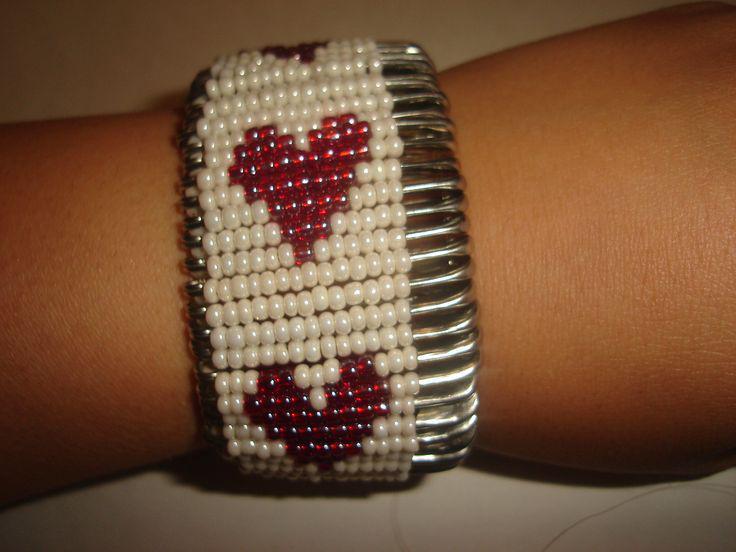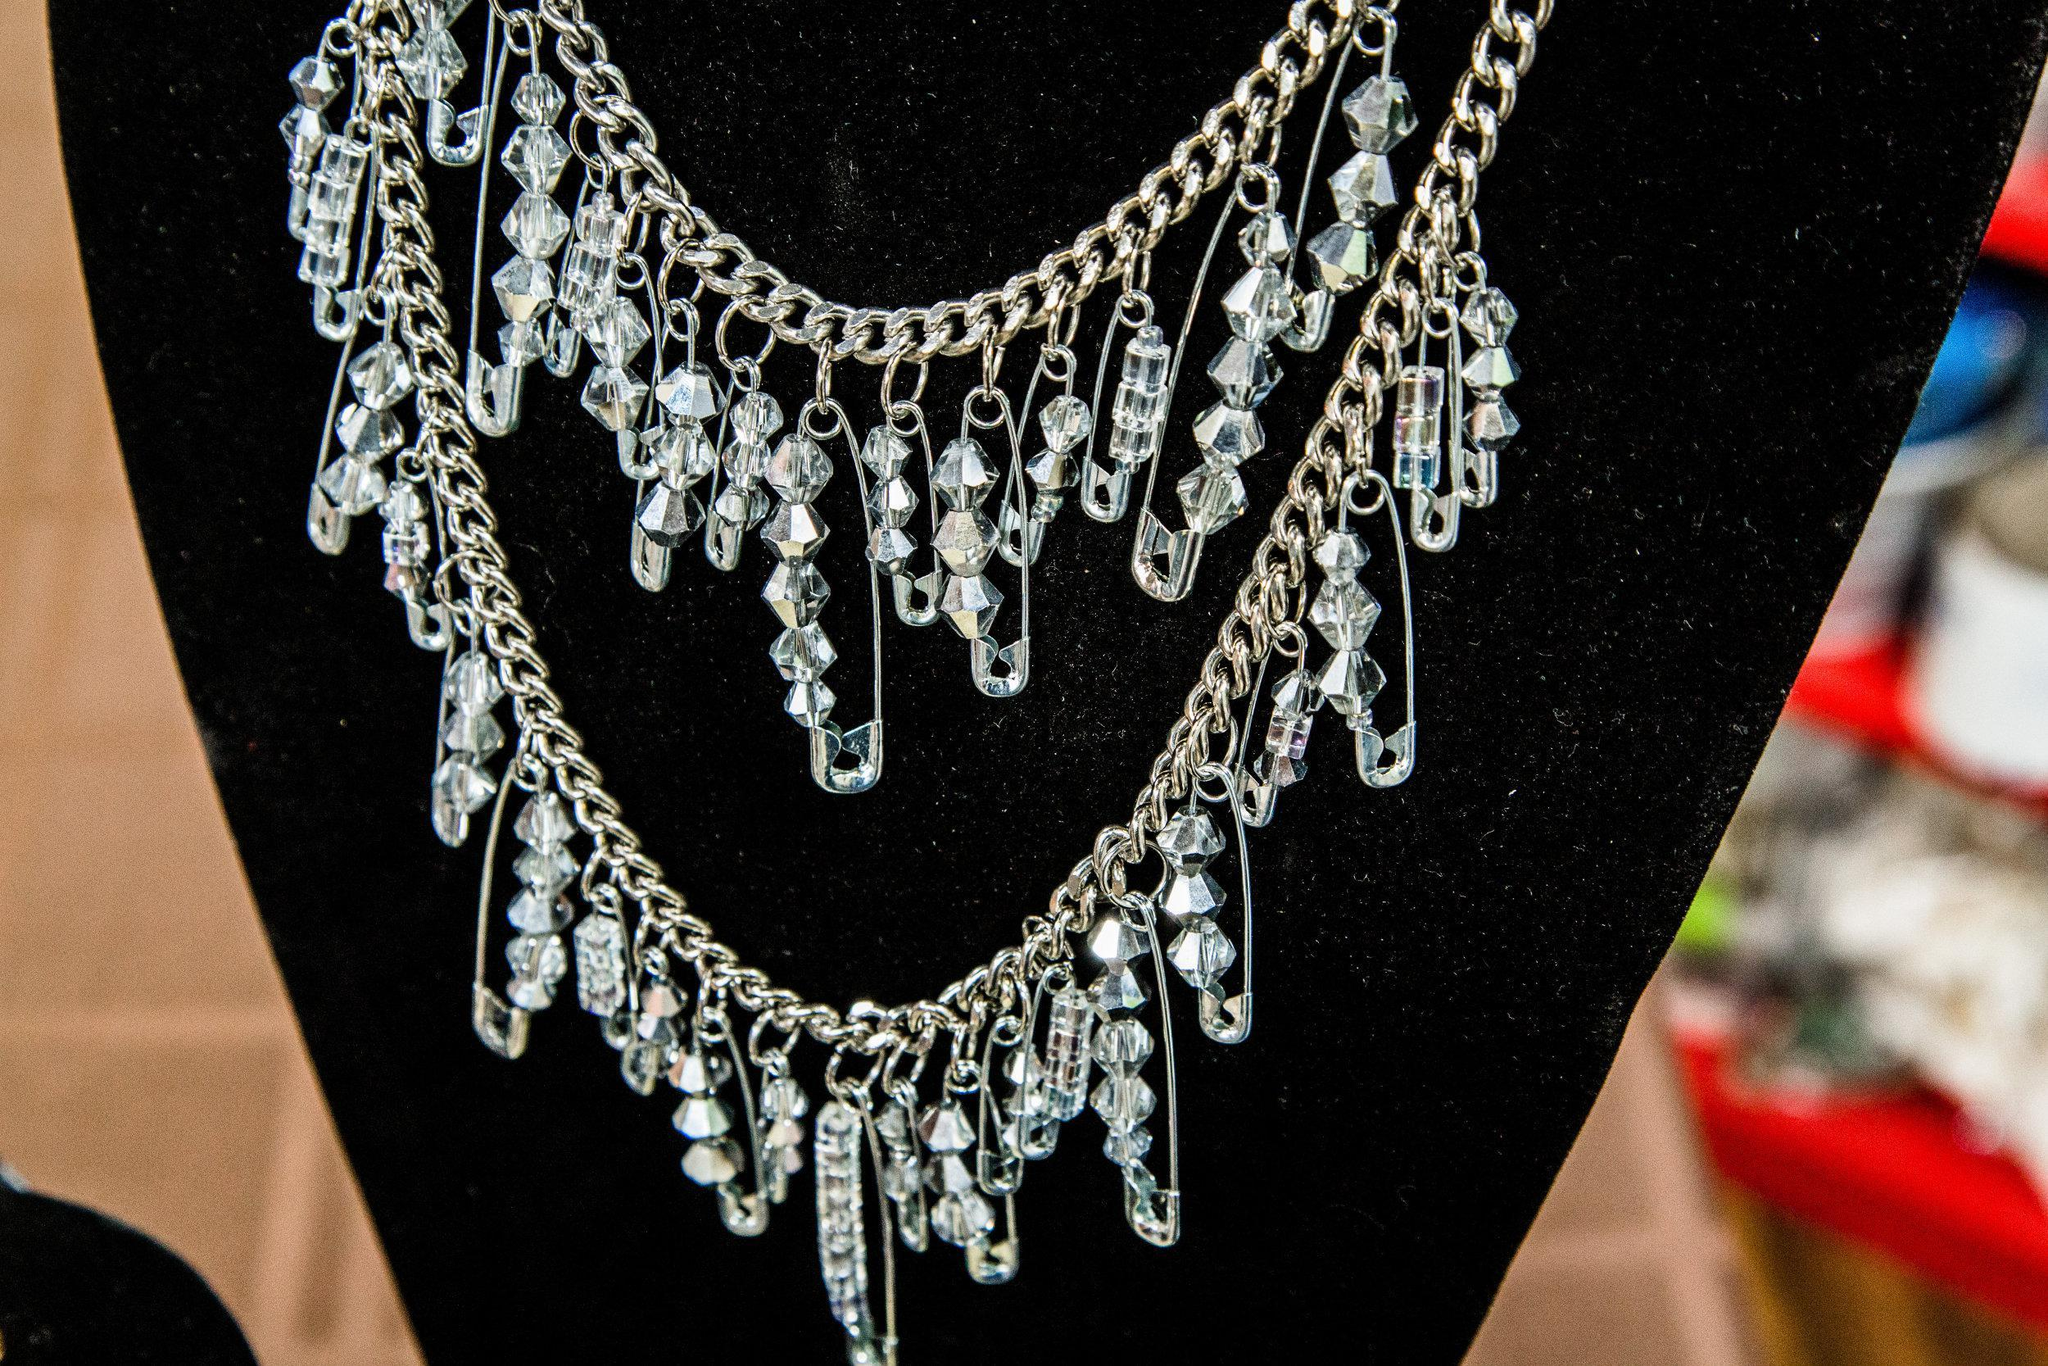The first image is the image on the left, the second image is the image on the right. For the images displayed, is the sentence "A bracelet is lying on a surface in each of the images." factually correct? Answer yes or no. No. The first image is the image on the left, the second image is the image on the right. Examine the images to the left and right. Is the description "One image shows a safety pin necklace on a black display, and the other image shows a bracelet made with silver safety pins." accurate? Answer yes or no. Yes. 